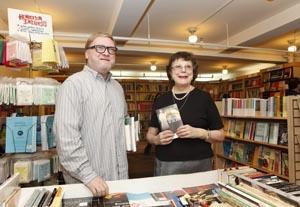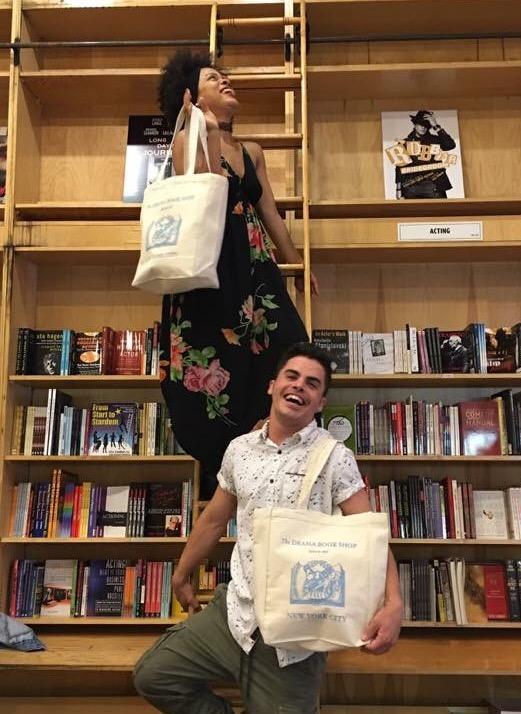The first image is the image on the left, the second image is the image on the right. For the images shown, is this caption "there are two people in the image on the left." true? Answer yes or no. Yes. The first image is the image on the left, the second image is the image on the right. Evaluate the accuracy of this statement regarding the images: "One image is inside a bookshop and one image is outside a bookshop.". Is it true? Answer yes or no. No. 